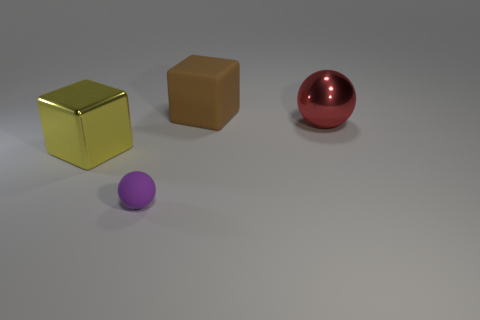There is a tiny thing; what shape is it?
Your answer should be very brief. Sphere. Is there any other thing that is the same size as the purple rubber ball?
Your response must be concise. No. Is the number of large brown cubes that are in front of the big sphere greater than the number of big red spheres?
Ensure brevity in your answer.  No. The matte object right of the rubber object in front of the big metallic object on the left side of the small rubber object is what shape?
Make the answer very short. Cube. There is a sphere that is in front of the shiny sphere; does it have the same size as the shiny cube?
Offer a very short reply. No. What shape is the large thing that is both on the right side of the yellow shiny thing and left of the metallic ball?
Your answer should be compact. Cube. There is a small rubber object; is it the same color as the rubber object behind the small purple matte sphere?
Your answer should be compact. No. There is a block that is behind the large thing that is on the left side of the object that is in front of the yellow cube; what color is it?
Offer a very short reply. Brown. What color is the other big thing that is the same shape as the big yellow object?
Offer a very short reply. Brown. Are there the same number of large red objects behind the brown matte block and small green cubes?
Ensure brevity in your answer.  Yes. 